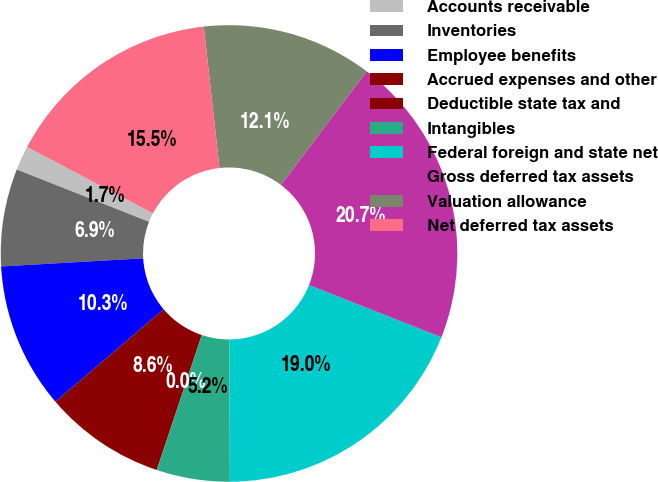Convert chart. <chart><loc_0><loc_0><loc_500><loc_500><pie_chart><fcel>Accounts receivable<fcel>Inventories<fcel>Employee benefits<fcel>Accrued expenses and other<fcel>Deductible state tax and<fcel>Intangibles<fcel>Federal foreign and state net<fcel>Gross deferred tax assets<fcel>Valuation allowance<fcel>Net deferred tax assets<nl><fcel>1.73%<fcel>6.9%<fcel>10.34%<fcel>8.62%<fcel>0.01%<fcel>5.18%<fcel>18.96%<fcel>20.68%<fcel>12.07%<fcel>15.51%<nl></chart> 